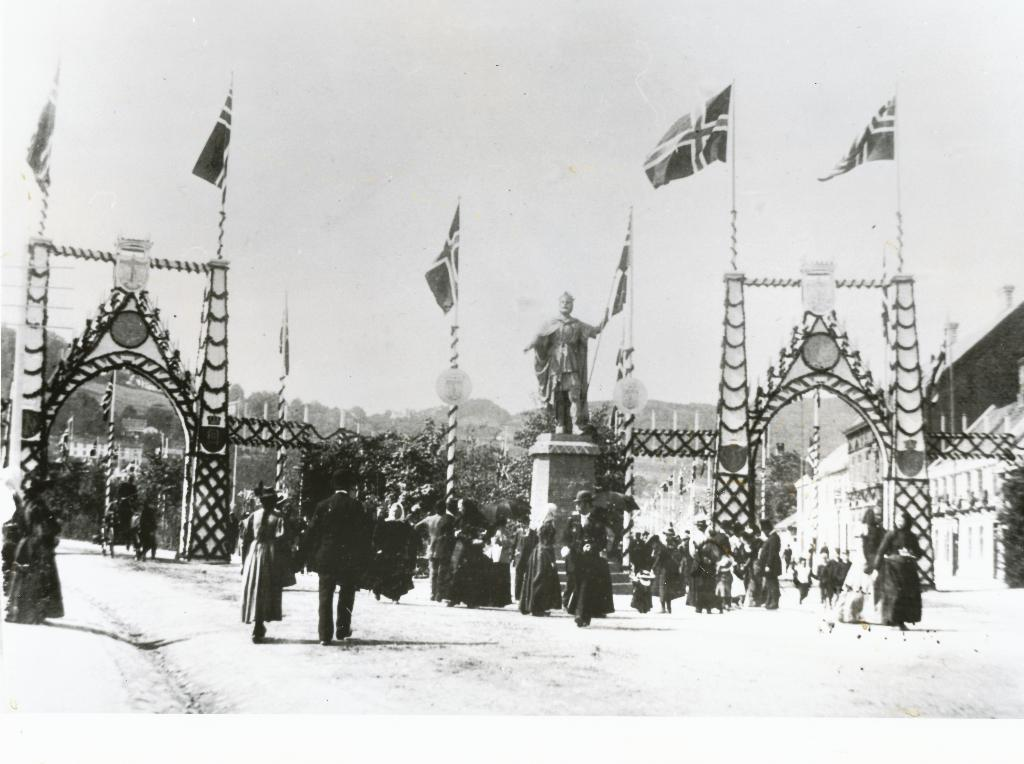What is located in the center of the image? There is a poster in the center of the image. What is the main subject of the poster? The poster features a statue in the center. What theory is being discussed by the boys in the image? There are no boys present in the image, and therefore no discussion or theory can be observed. 